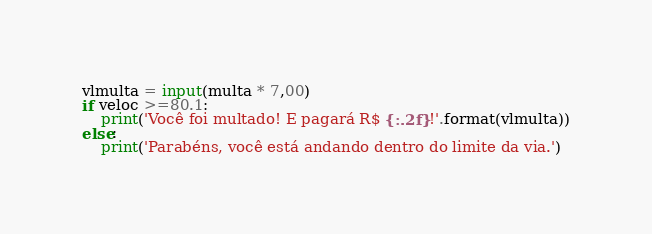<code> <loc_0><loc_0><loc_500><loc_500><_Python_>vlmulta = input(multa * 7,00)
if veloc >=80.1:
    print('Você foi multado! E pagará R$ {:.2f}!'.format(vlmulta))
else:
    print('Parabéns, você está andando dentro do limite da via.')

</code> 